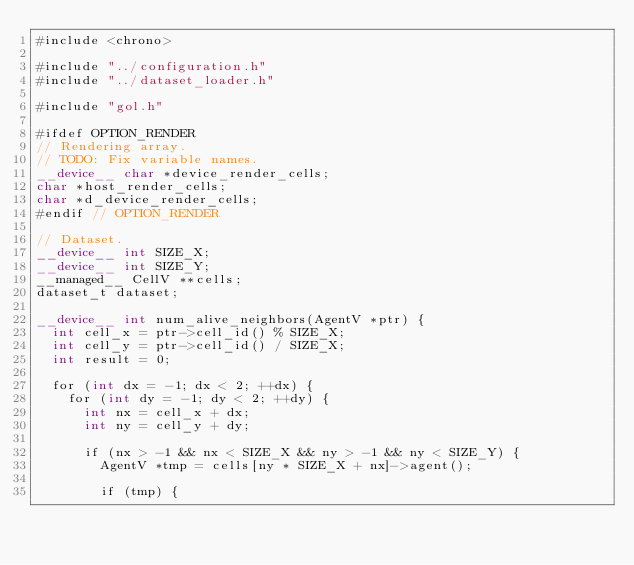<code> <loc_0><loc_0><loc_500><loc_500><_Cuda_>#include <chrono>

#include "../configuration.h"
#include "../dataset_loader.h"

#include "gol.h"

#ifdef OPTION_RENDER
// Rendering array.
// TODO: Fix variable names.
__device__ char *device_render_cells;
char *host_render_cells;
char *d_device_render_cells;
#endif // OPTION_RENDER

// Dataset.
__device__ int SIZE_X;
__device__ int SIZE_Y;
__managed__ CellV **cells;
dataset_t dataset;

__device__ int num_alive_neighbors(AgentV *ptr) {
  int cell_x = ptr->cell_id() % SIZE_X;
  int cell_y = ptr->cell_id() / SIZE_X;
  int result = 0;

  for (int dx = -1; dx < 2; ++dx) {
    for (int dy = -1; dy < 2; ++dy) {
      int nx = cell_x + dx;
      int ny = cell_y + dy;

      if (nx > -1 && nx < SIZE_X && ny > -1 && ny < SIZE_Y) {
        AgentV *tmp = cells[ny * SIZE_X + nx]->agent();
       
        if (tmp) {</code> 